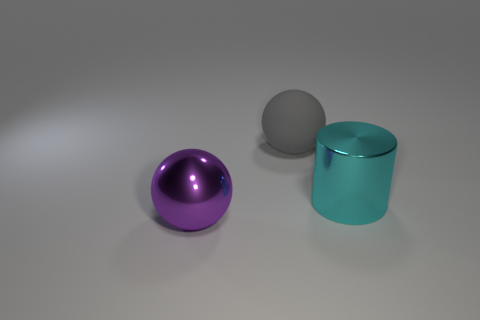Add 3 blue metal cylinders. How many objects exist? 6 Subtract 2 balls. How many balls are left? 0 Subtract all cylinders. How many objects are left? 2 Add 3 large cyan objects. How many large cyan objects are left? 4 Add 2 large brown blocks. How many large brown blocks exist? 2 Subtract 0 yellow blocks. How many objects are left? 3 Subtract all brown cylinders. Subtract all brown blocks. How many cylinders are left? 1 Subtract all small cyan cylinders. Subtract all big purple metallic objects. How many objects are left? 2 